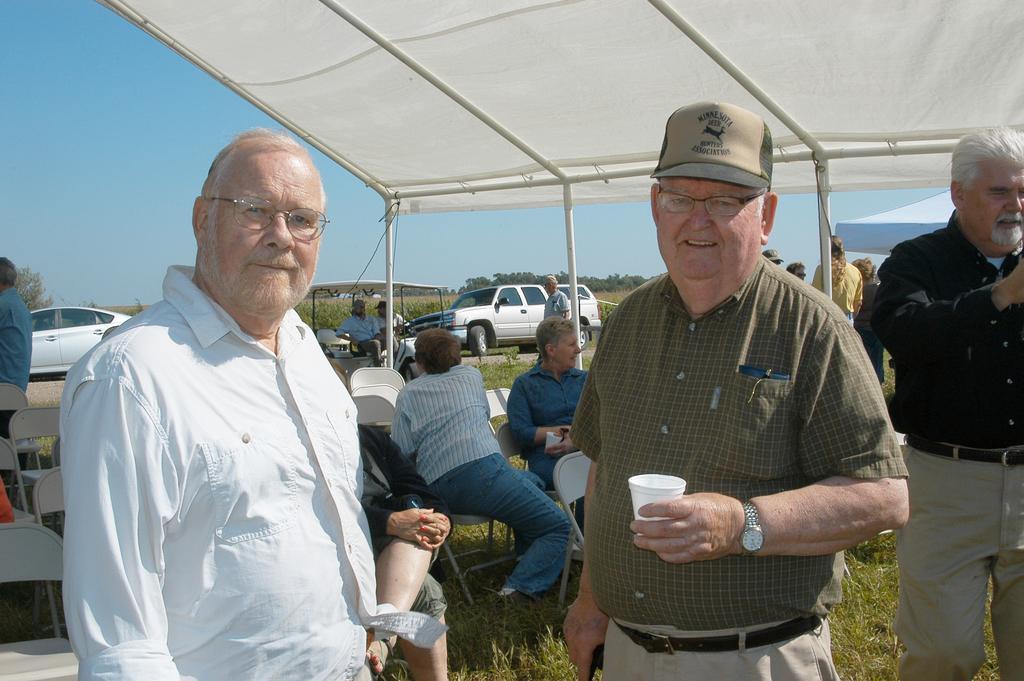How would you summarize this image in a sentence or two? In the center of the image we can see three persons are standing and they are in different costumes. Among them, we can see one person is holding a glass and he is wearing a cap and we can see he is smiling. In the background, we can see the sky, trees, vehicles, grass, tents, chairs, few people are standing, few people are sitting and a few other objects. 